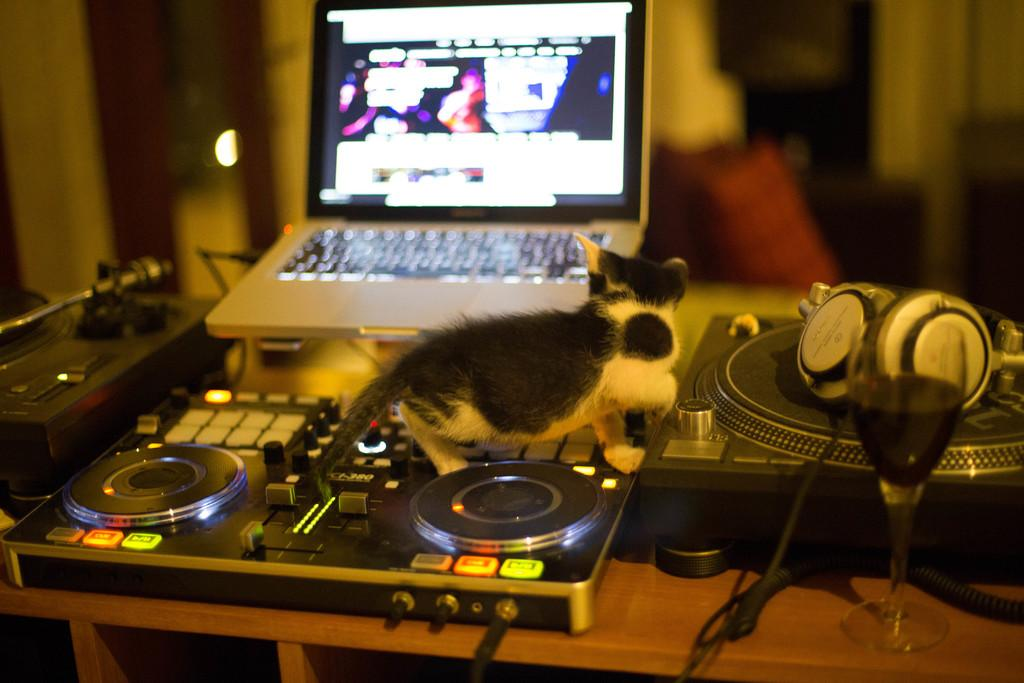What type of animal is in the image? There is a cat in the image. Where is the cat located? The cat is on a device. What is the device placed on? The device is placed on a table. What other electronic devices can be seen in the image? There is a laptop, a microphone (mic), and headphones in the image. What type of container is present in the image? There is a glass in the image. Are there any other devices or objects in the image? Yes, there are additional devices present in the image. What type of shirt is the hen wearing in the image? There is no hen or shirt present in the image; it features a cat on a device. What type of teeth can be seen in the image? There are no teeth visible in the image, as it features electronic devices and a cat. 